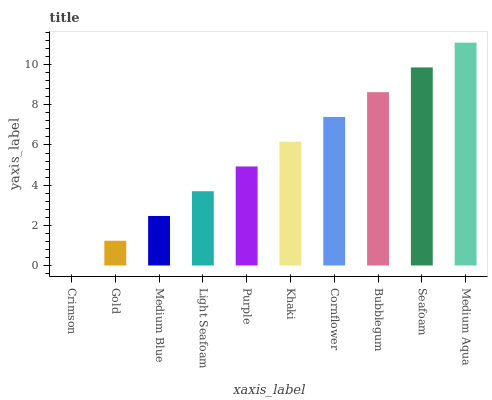Is Crimson the minimum?
Answer yes or no. Yes. Is Medium Aqua the maximum?
Answer yes or no. Yes. Is Gold the minimum?
Answer yes or no. No. Is Gold the maximum?
Answer yes or no. No. Is Gold greater than Crimson?
Answer yes or no. Yes. Is Crimson less than Gold?
Answer yes or no. Yes. Is Crimson greater than Gold?
Answer yes or no. No. Is Gold less than Crimson?
Answer yes or no. No. Is Khaki the high median?
Answer yes or no. Yes. Is Purple the low median?
Answer yes or no. Yes. Is Seafoam the high median?
Answer yes or no. No. Is Medium Blue the low median?
Answer yes or no. No. 